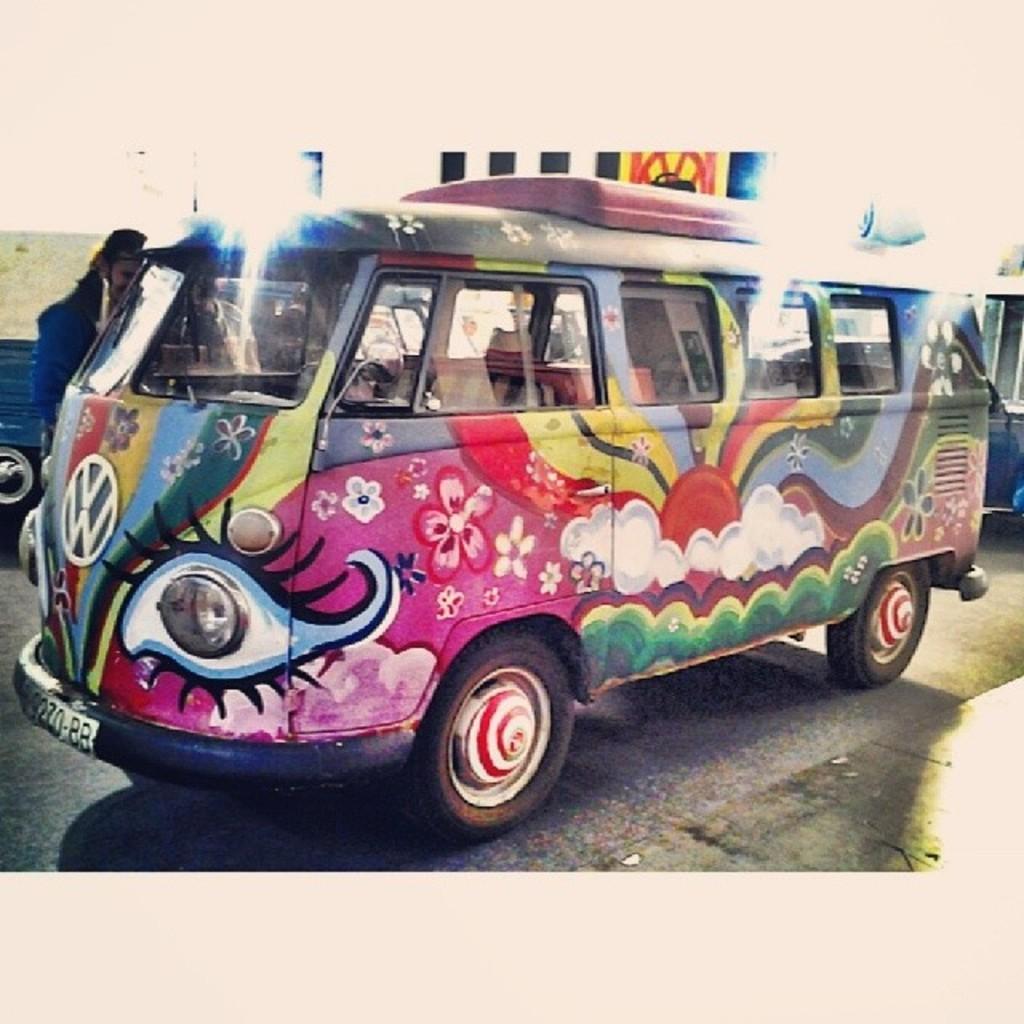Can you describe this image briefly? This picture might be outside of the city and it is sunny. In this image, in the middle, we can see a van which is placed on the road. On the right side corner, we can also see a vehicle. On the left side, we can see a person and a vehicle. On the top, we can see a sky, at the bottom there is a road. 